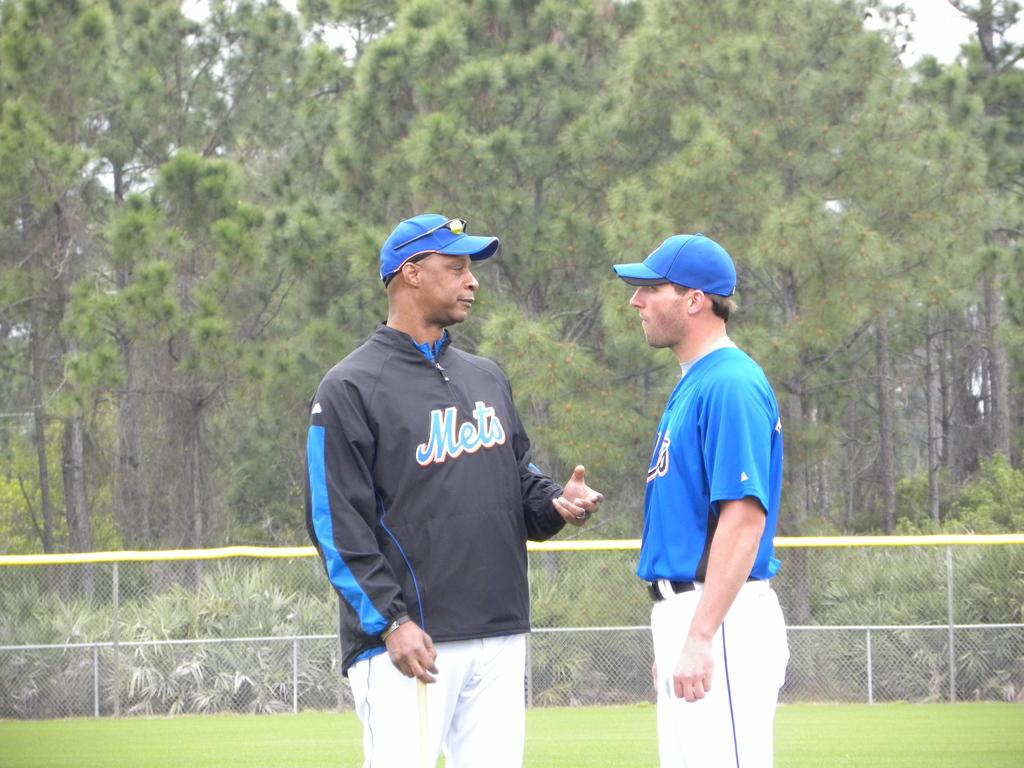<image>
Write a terse but informative summary of the picture. Two men in Mets clothing have a conversation on a baseball field. 